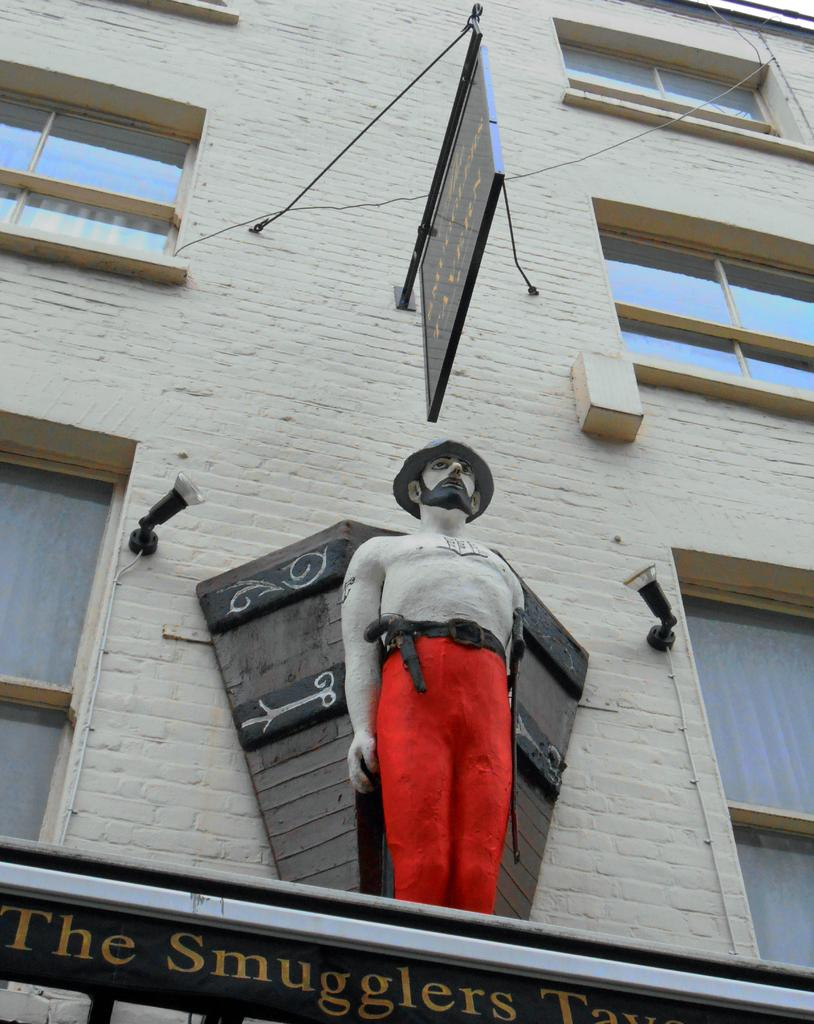What type of structure is visible in the image? There is a building in the image. What feature can be observed on the building? The building has glass windows. What is written or displayed on a board in the image? There is a board with text in the image. What type of object is present in the image that represents a person or figure? There is a statue in the image. What type of illumination is present on the wall in the image? There are lights on the wall in the image. What can be read or seen at the bottom of the image? There is text at the bottom of the image. What is the amount of smell that can be detected in the image? There is no mention of smell in the image, so it cannot be determined. 